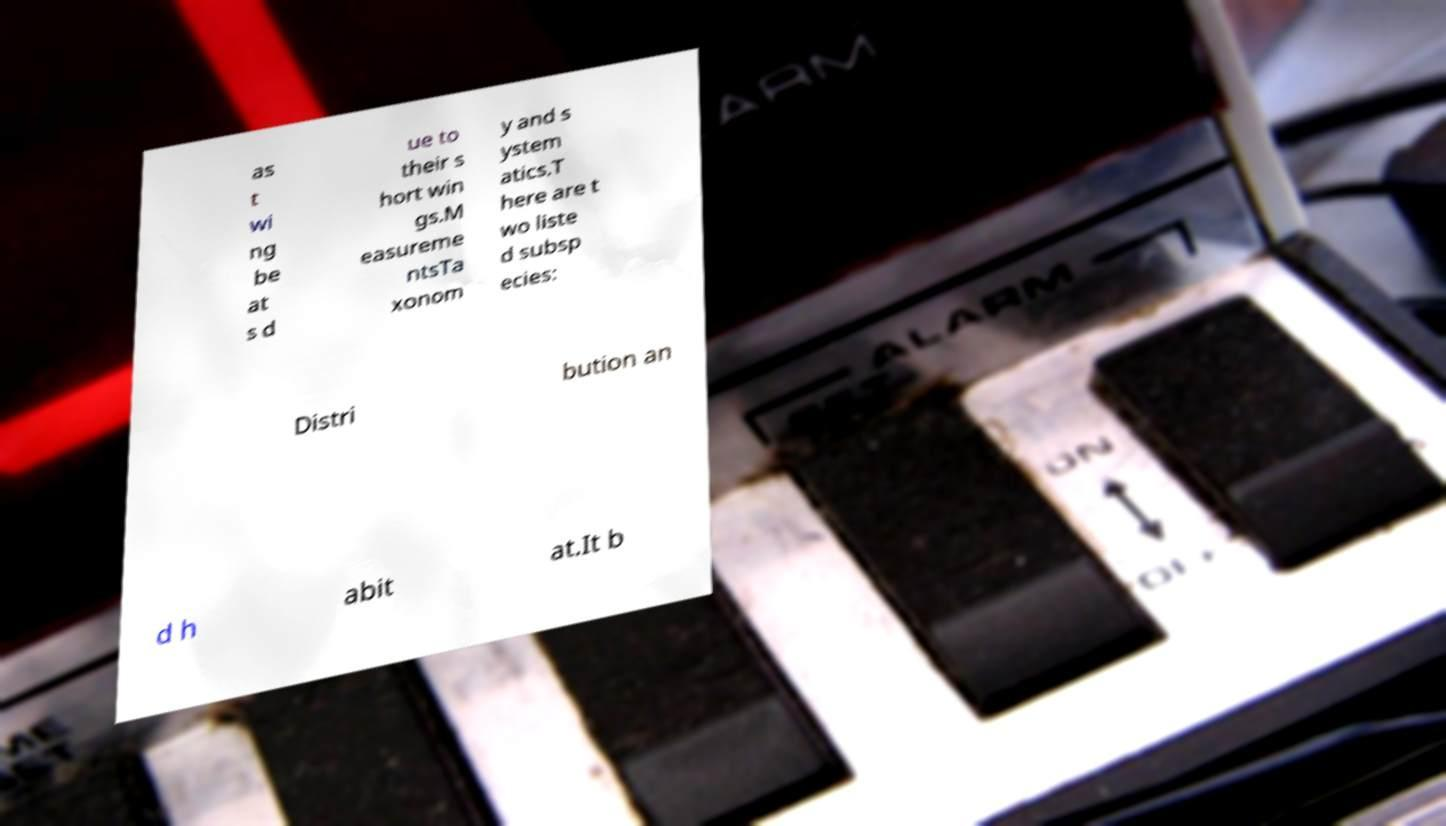Please identify and transcribe the text found in this image. as t wi ng be at s d ue to their s hort win gs.M easureme ntsTa xonom y and s ystem atics.T here are t wo liste d subsp ecies: Distri bution an d h abit at.It b 